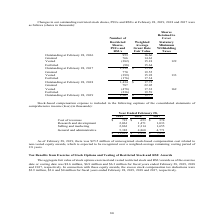According to Calamp's financial document, As of February 28,2019, how much unrecognized stock-based compensation cost related to non-vested equity awards were there? According to the financial document, $25.5 million (in millions). The relevant text states: "As of February 28, 2019, there was $25.5 million of unrecognized stock-based compensation cost related to non-vested equity awards, which is expected..." Also, How much was the cost of revenues in 2017? According to the financial document, $374 (in thousands). The relevant text states: "28, 2019 2018 2017 Cost of revenues $ 723 $ 653 $ 374 Research and development 2,061 1,471 1,033 Selling and marketing 2,863 2,314 1,655 General and admi..." Also, How much was the cost of revenues in 2019? According to the financial document, $723 (in thousands). The relevant text states: "ed February 28, 2019 2018 2017 Cost of revenues $ 723 $ 653 $ 374 Research and development 2,061 1,471 1,033 Selling and marketing 2,863 2,314 1,655 Gene..." Also, can you calculate: What was the change in Research and Development between 2018 and 2019? Based on the calculation: (2,061-1,471), the result is 590 (in thousands). This is based on the information: "venues $ 723 $ 653 $ 374 Research and development 2,061 1,471 1,033 Selling and marketing 2,863 2,314 1,655 General and administrative 5,382 4,860 4,771 $ $ 723 $ 653 $ 374 Research and development 2,..." The key data points involved are: 1,471, 2,061. Also, can you calculate: What was the change in Selling and marketing between 2018 and 2019? Based on the calculation: (2,863-2,314), the result is 549 (in thousands). This is based on the information: "ent 2,061 1,471 1,033 Selling and marketing 2,863 2,314 1,655 General and administrative 5,382 4,860 4,771 $ 11,029 $ 9,298 $ 7,833 velopment 2,061 1,471 1,033 Selling and marketing 2,863 2,314 1,655 ..." The key data points involved are: 2,314, 2,863. Also, can you calculate: How much was General and Administrative in 2019 as a percentage of the total in 2019? Based on the calculation: (5,382/11,029), the result is 48.8 (percentage). This is based on the information: "55 General and administrative 5,382 4,860 4,771 $ 11,029 $ 9,298 $ 7,833 ting 2,863 2,314 1,655 General and administrative 5,382 4,860 4,771 $ 11,029 $ 9,298 $ 7,833..." The key data points involved are: 11,029, 5,382. 